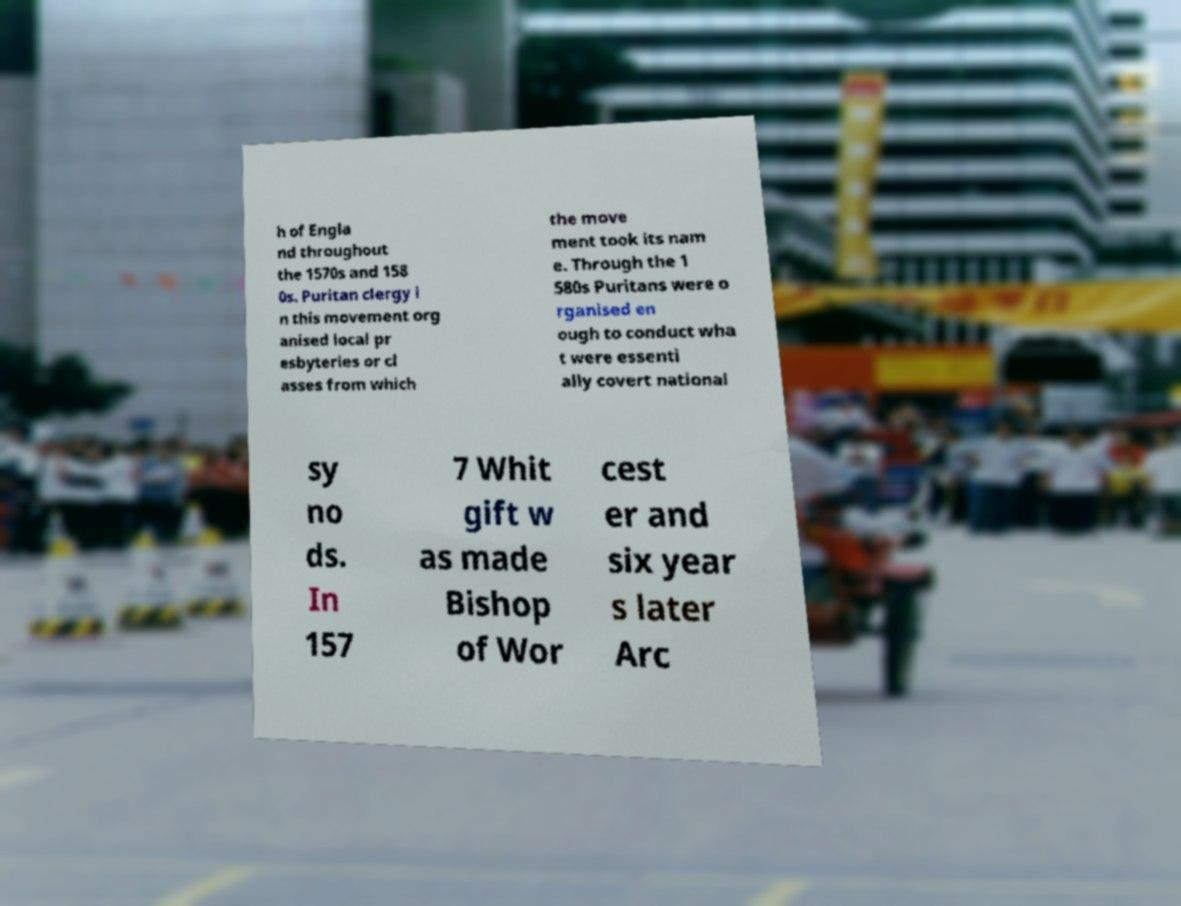Could you extract and type out the text from this image? h of Engla nd throughout the 1570s and 158 0s. Puritan clergy i n this movement org anised local pr esbyteries or cl asses from which the move ment took its nam e. Through the 1 580s Puritans were o rganised en ough to conduct wha t were essenti ally covert national sy no ds. In 157 7 Whit gift w as made Bishop of Wor cest er and six year s later Arc 